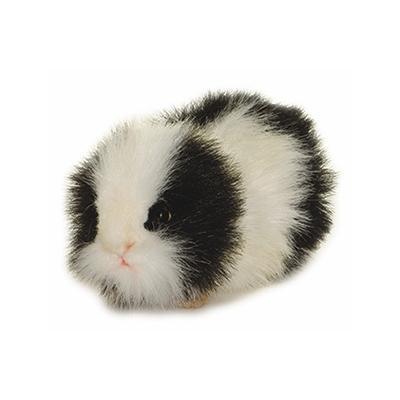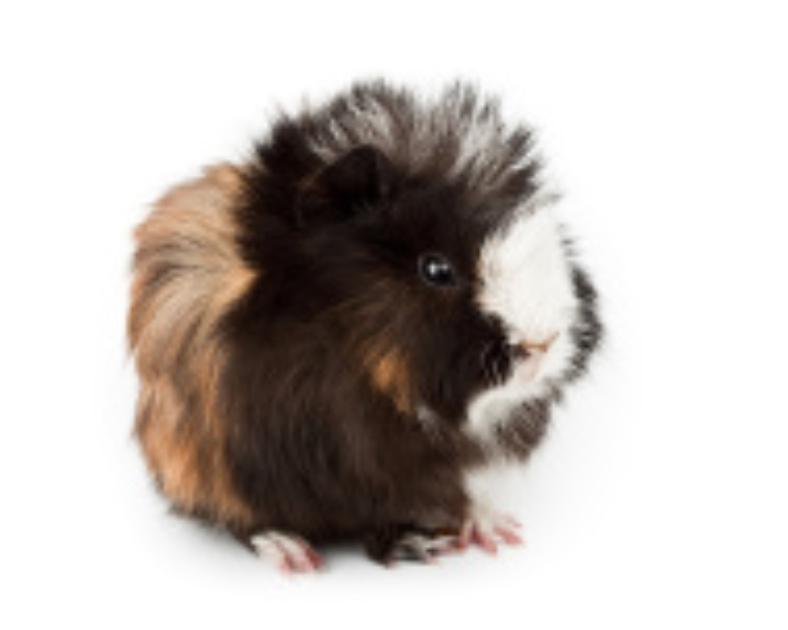The first image is the image on the left, the second image is the image on the right. Given the left and right images, does the statement "There is at least two rodents in the right image." hold true? Answer yes or no. No. The first image is the image on the left, the second image is the image on the right. Examine the images to the left and right. Is the description "There are exactly two guinea pigs in total." accurate? Answer yes or no. Yes. 